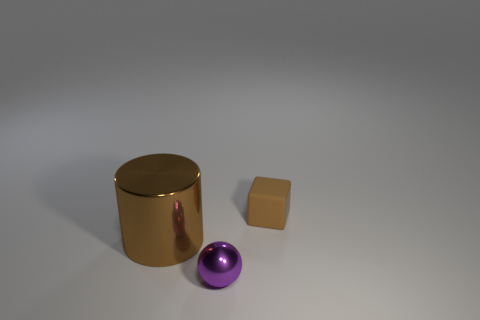Add 2 tiny spheres. How many objects exist? 5 Subtract all cylinders. How many objects are left? 2 Add 1 large red metal balls. How many large red metal balls exist? 1 Subtract 0 green cubes. How many objects are left? 3 Subtract all brown blocks. Subtract all small shiny spheres. How many objects are left? 1 Add 1 purple metallic things. How many purple metallic things are left? 2 